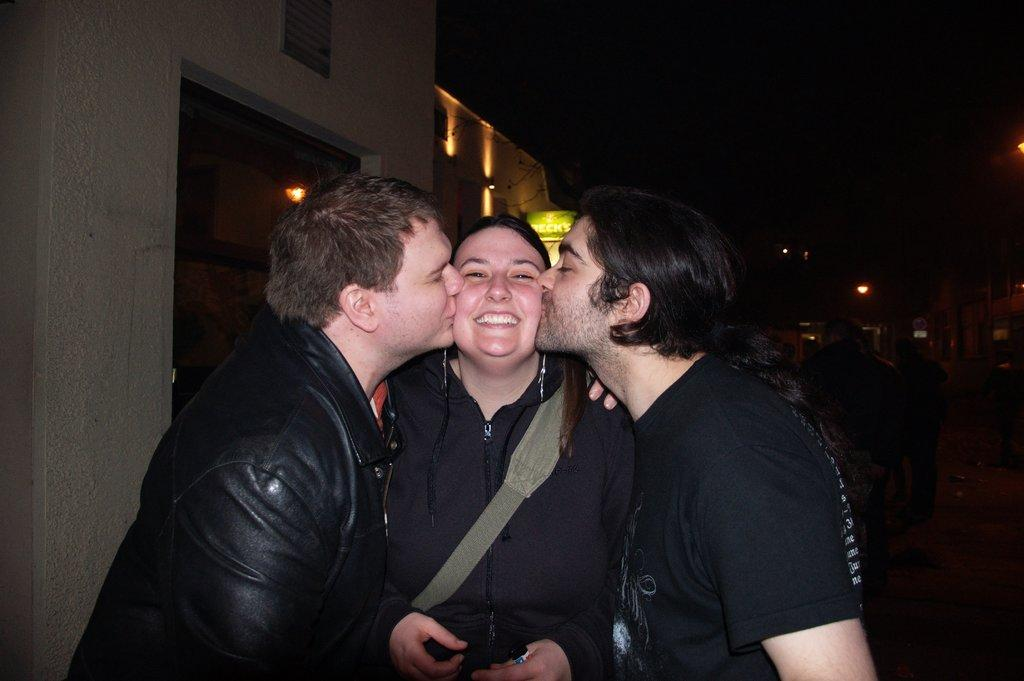How many people are present in the image? There are three people in the image: two men and a woman. What are the men doing to the woman? The men are kissing the woman on her cheeks. How does the woman react to the men's actions? The woman is smiling. What can be seen in the background of the image? There are buildings visible in the image. What caption would best describe the pet in the image? There is no pet present in the image, so it is not possible to provide a caption for one. 